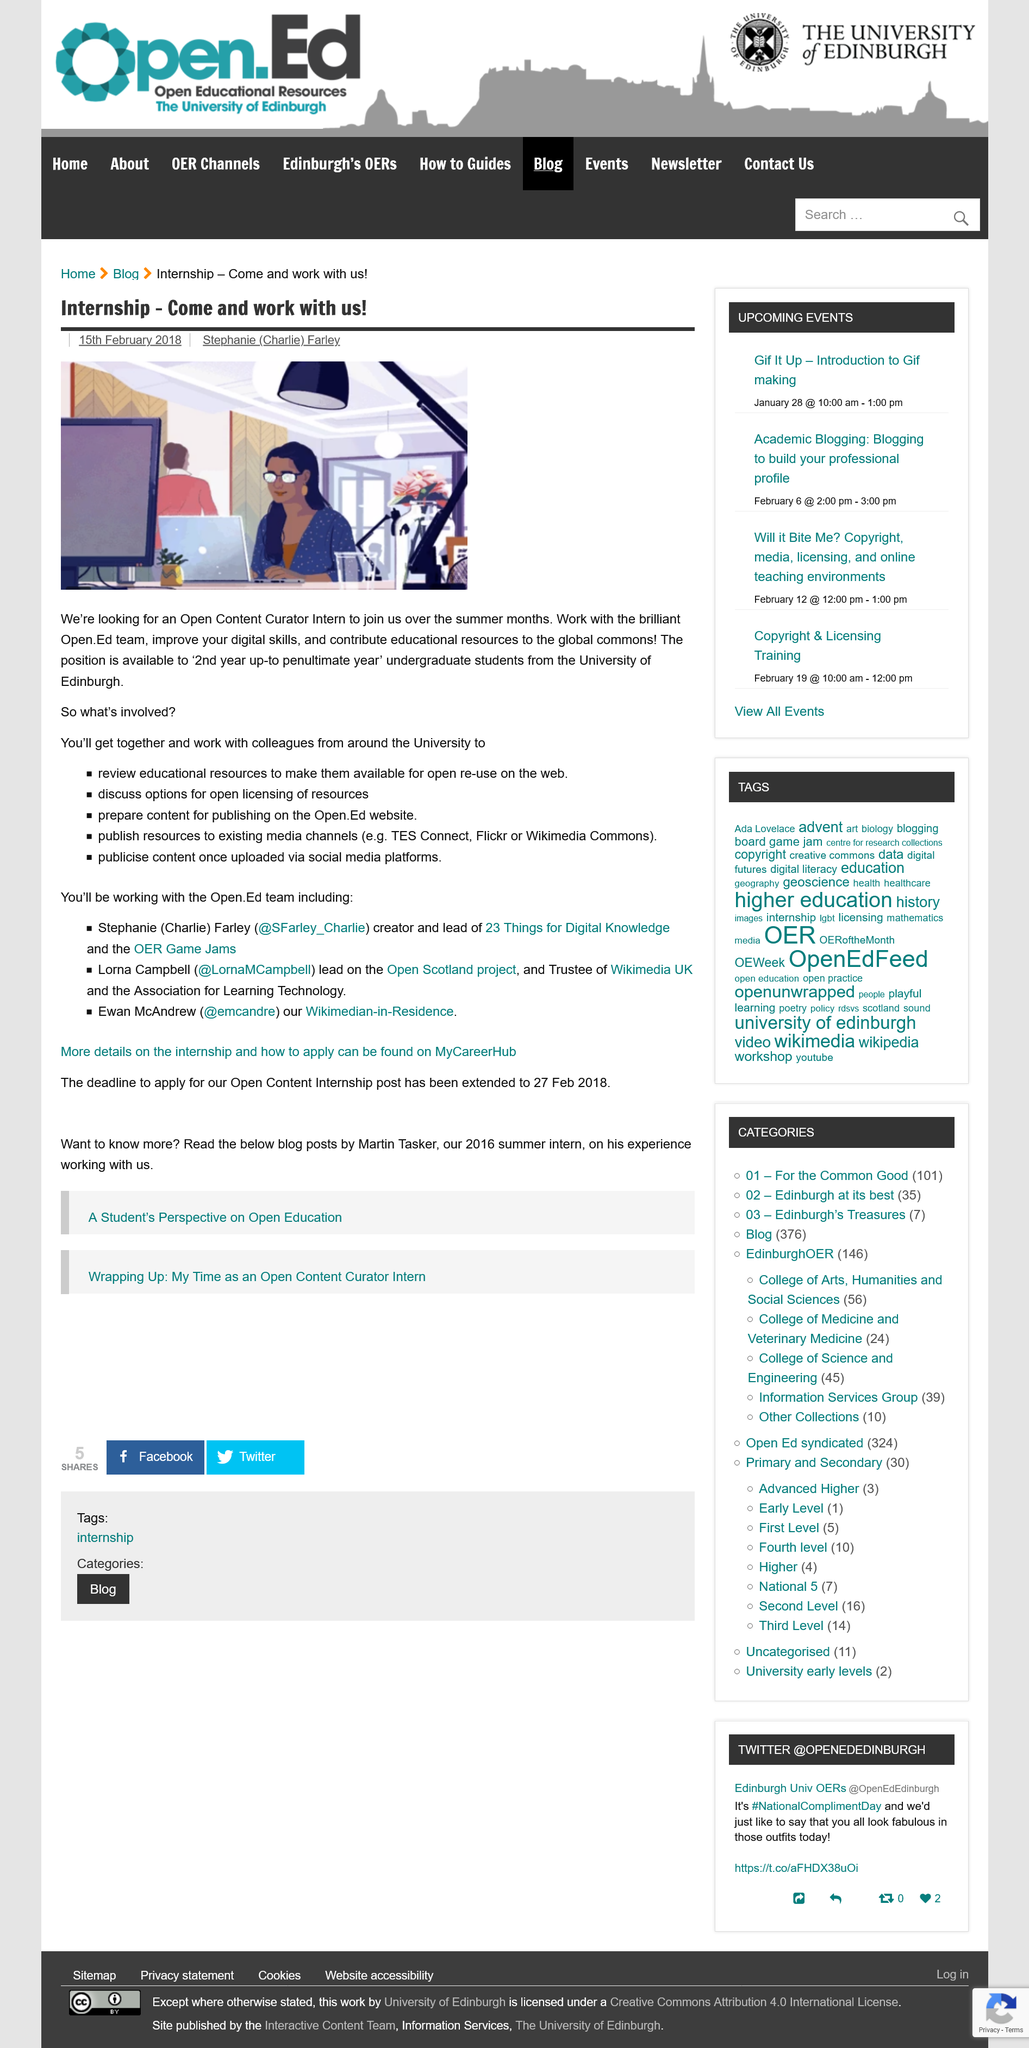Mention a couple of crucial points in this snapshot. The position advertised is for an Open Content Curator. The position of Open Content Curator is with the University of Edinburgh. The opportunity allows for collaboration with University colleagues to explore open licensing options for resources. 